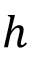<formula> <loc_0><loc_0><loc_500><loc_500>h</formula> 